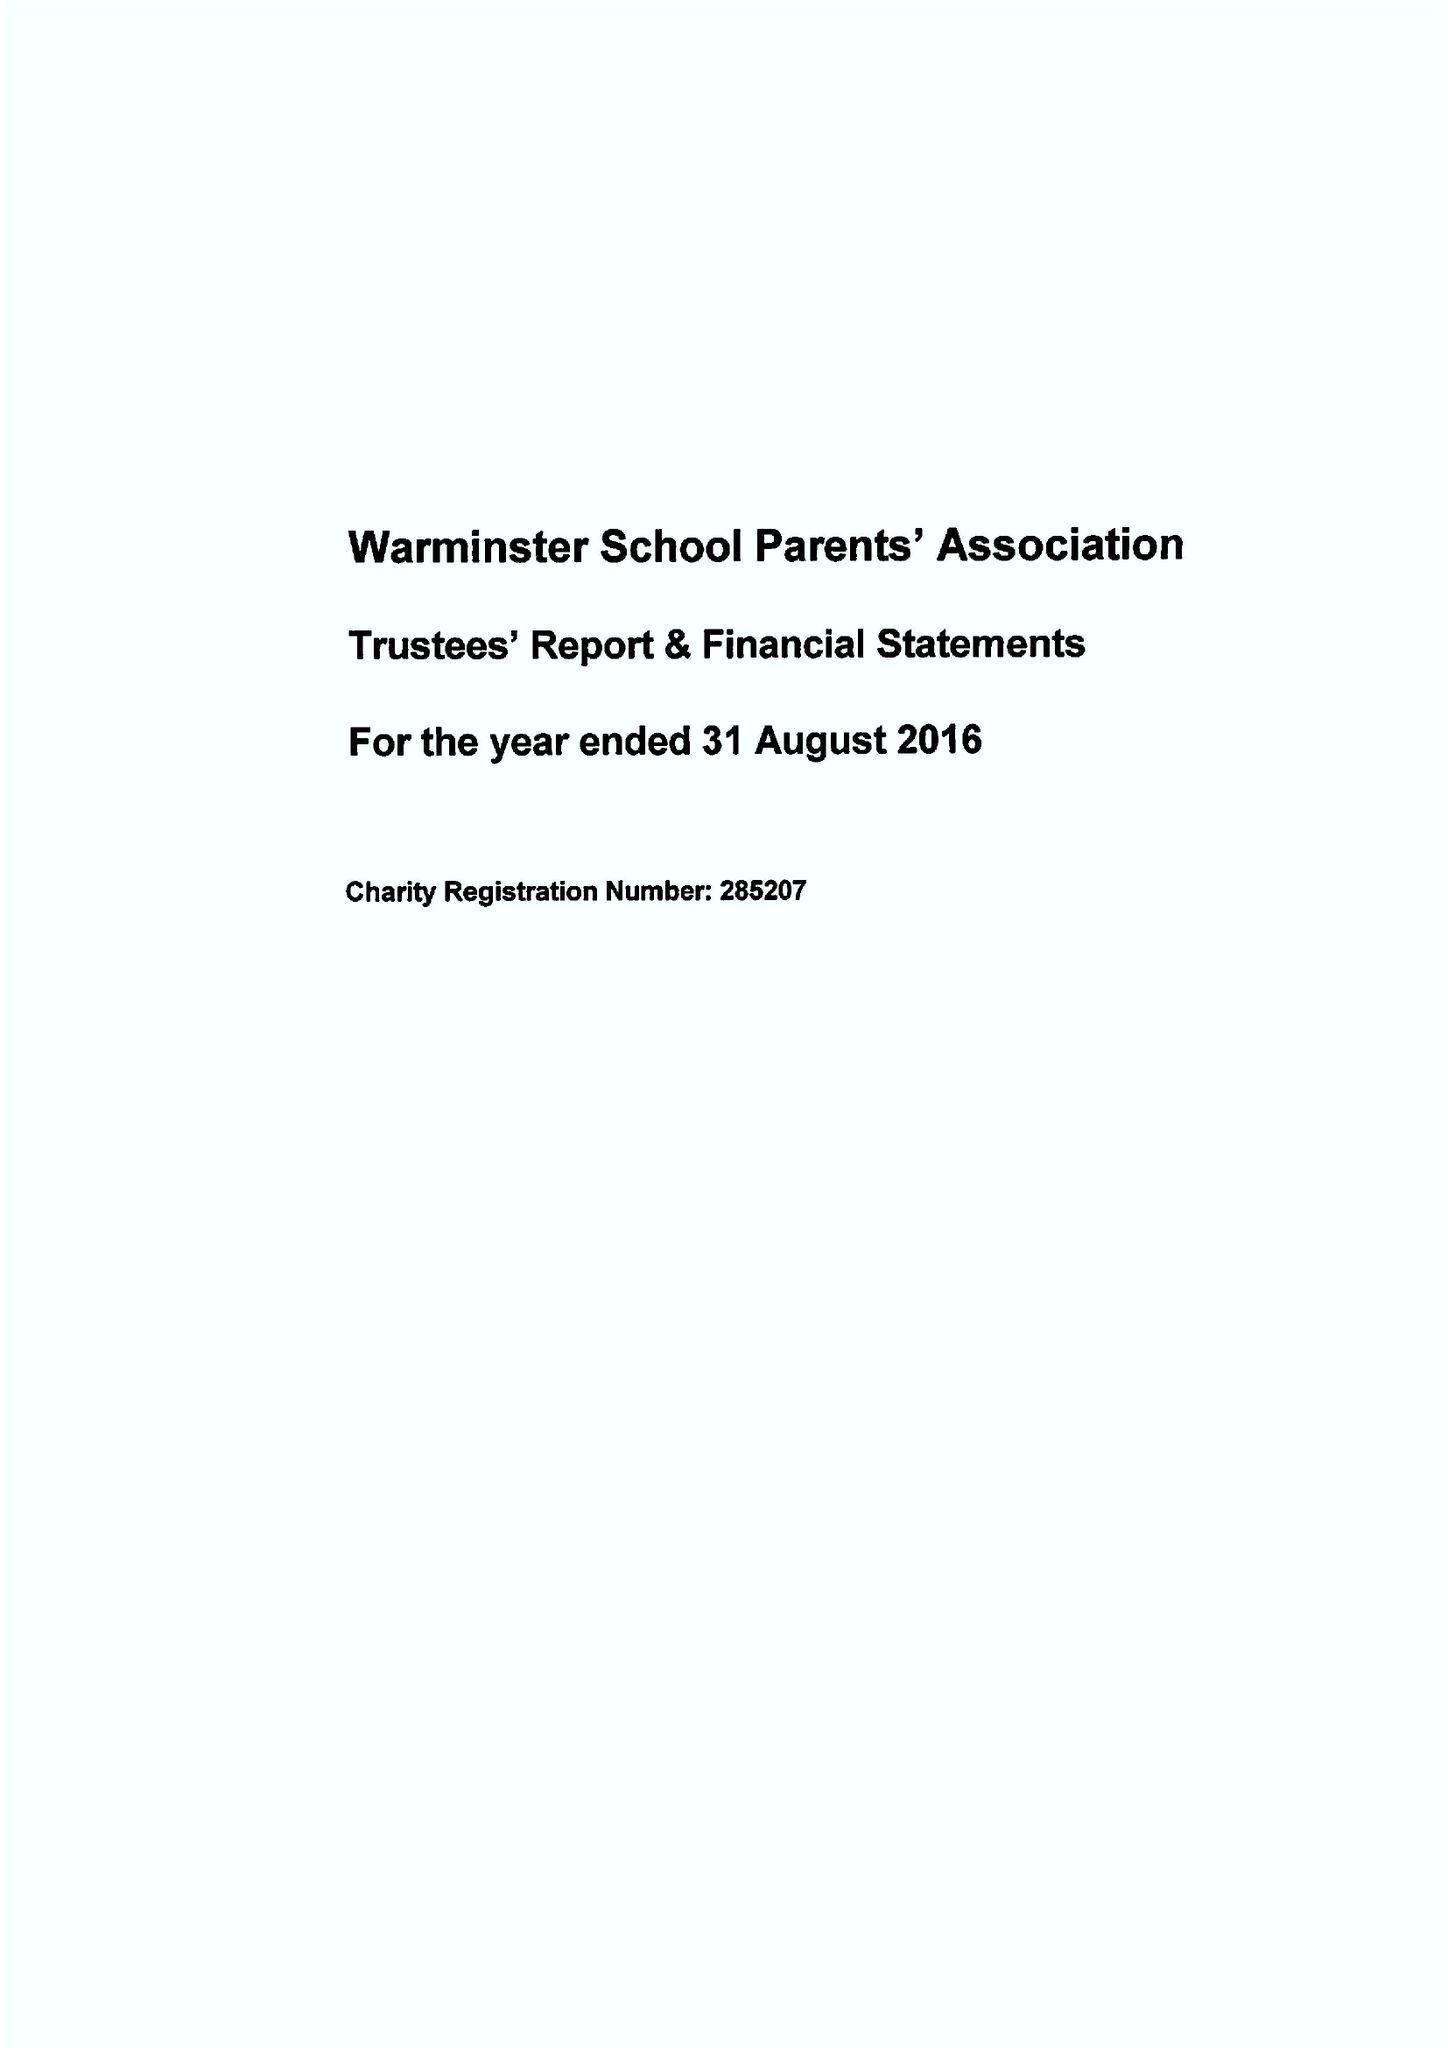What is the value for the report_date?
Answer the question using a single word or phrase. 2016-08-31 